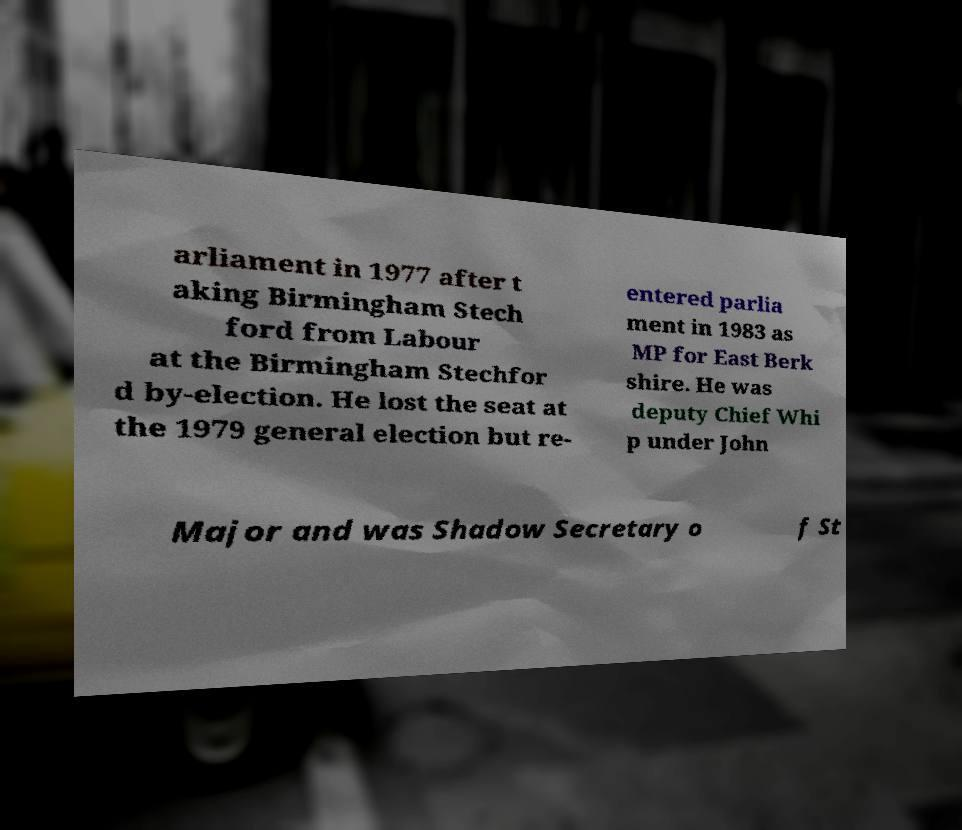Please read and relay the text visible in this image. What does it say? arliament in 1977 after t aking Birmingham Stech ford from Labour at the Birmingham Stechfor d by-election. He lost the seat at the 1979 general election but re- entered parlia ment in 1983 as MP for East Berk shire. He was deputy Chief Whi p under John Major and was Shadow Secretary o f St 